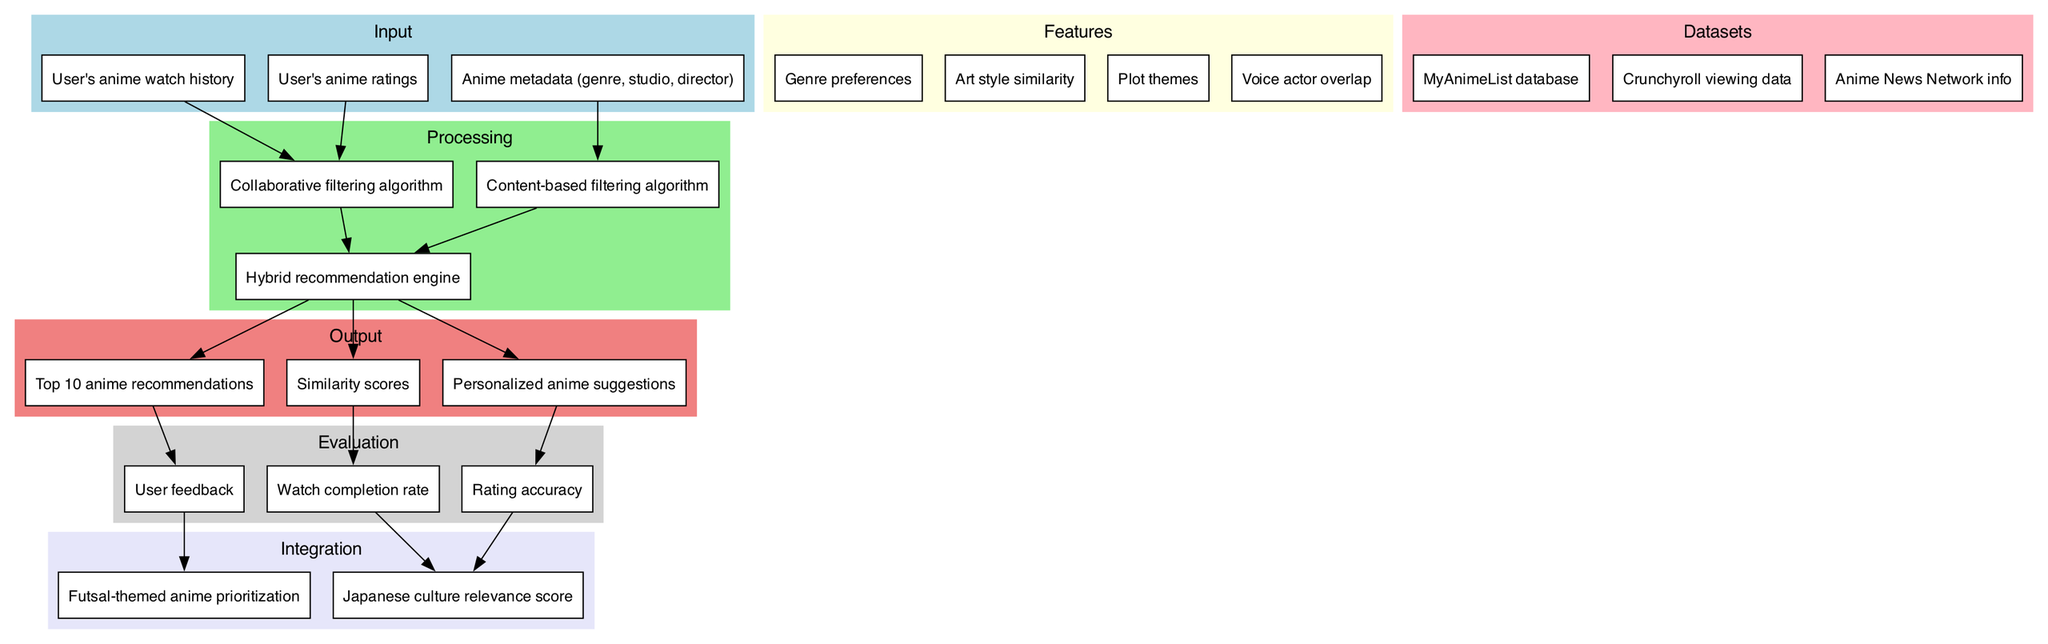What are the inputs to the anime recommendation system? The diagram lists three inputs: "User's anime watch history," "User's anime ratings," and "Anime metadata (genre, studio, director)."
Answer: User's anime watch history, User's anime ratings, Anime metadata (genre, studio, director) How many features are considered in the recommendation system? According to the diagram, there are four features listed: Genre preferences, Art style similarity, Plot themes, and Voice actor overlap.
Answer: Four What is the output of the hybrid recommendation engine? The hybrid recommendation engine produces three outputs: "Top 10 anime recommendations," "Similarity scores," and "Personalized anime suggestions."
Answer: Top 10 anime recommendations, Similarity scores, Personalized anime suggestions Which processing algorithm uses anime metadata as input? The diagram indicates that "Anime metadata (genre, studio, director)" is used as input for the "Content-based filtering algorithm."
Answer: Content-based filtering algorithm What influences the Japanese culture relevance score in the evaluation? From the diagram, both "Watch completion rate" and "Rating accuracy" contribute to the "Japanese culture relevance score."
Answer: Watch completion rate, Rating accuracy Which feature is related to the user's actual anime ratings? The "Collaborative filtering algorithm" processes the "User's anime ratings," making this the relevant feature.
Answer: Collaborative filtering algorithm What kind of evaluation method gathers user responses? The "User feedback" node in the diagram indicates that user responses are collected to evaluate the system.
Answer: User feedback What integration focuses on futsal-themed anime? The diagram specifies "Futsal-themed anime prioritization" as an integration aspect that prioritizes related content.
Answer: Futsal-themed anime prioritization How many datasets are used in the recommendation system? The diagram identifies three datasets: "MyAnimeList database," "Crunchyroll viewing data," and "Anime News Network info."
Answer: Three 